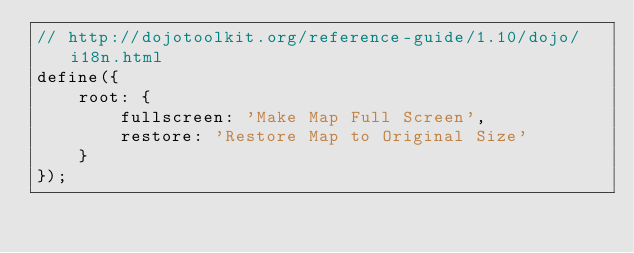Convert code to text. <code><loc_0><loc_0><loc_500><loc_500><_JavaScript_>// http://dojotoolkit.org/reference-guide/1.10/dojo/i18n.html
define({
    root: {
        fullscreen: 'Make Map Full Screen',
        restore: 'Restore Map to Original Size'
    }
});</code> 